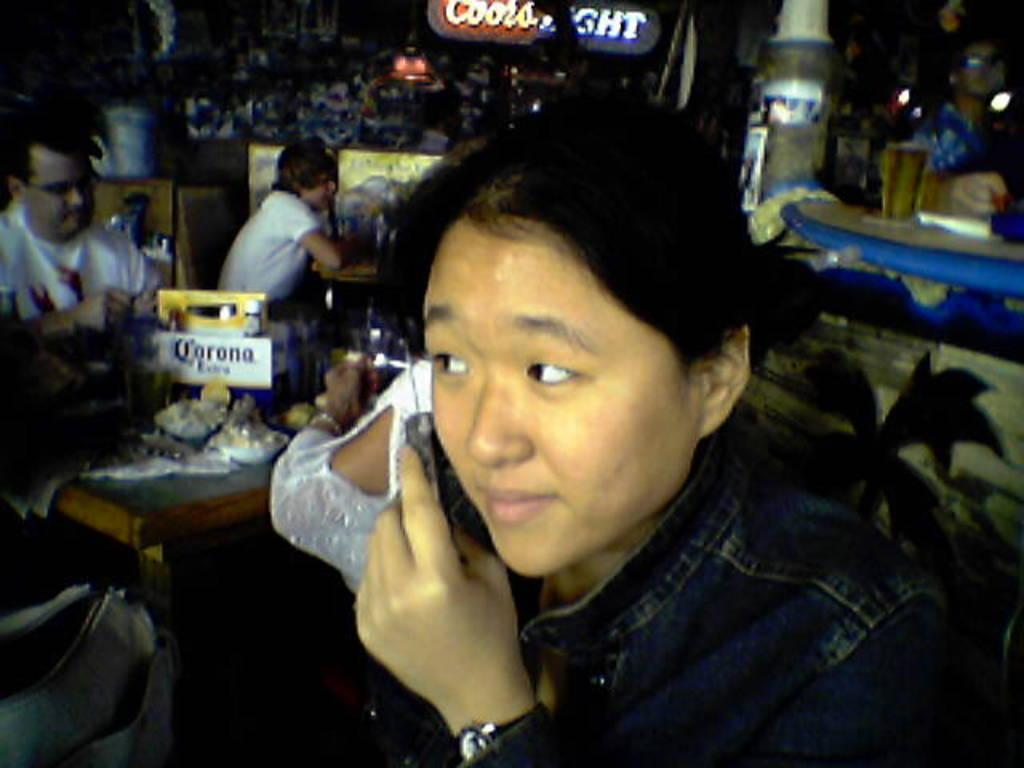Who or what is present in the image? There are people in the image. What can be seen hanging or displayed in the image? There is a banner in the image. What type of furniture is visible in the image? There are tables in the image. What material is present in the image? There is glass in the image. How would you describe the lighting in the image? The image is a little dark. What type of drug is being used by the people in the image? There is no indication of any drug use in the image; it only shows people, a banner, tables, and glass. 